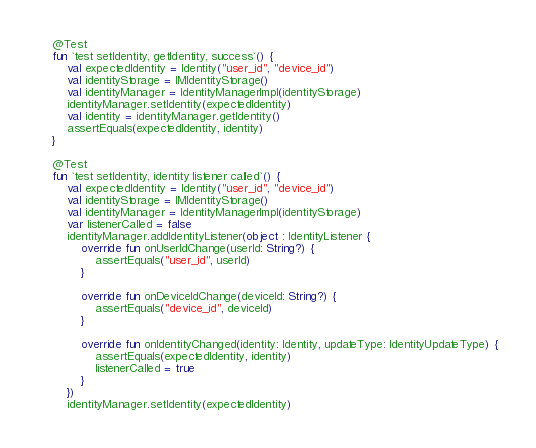Convert code to text. <code><loc_0><loc_0><loc_500><loc_500><_Kotlin_>    @Test
    fun `test setIdentity, getIdentity, success`() {
        val expectedIdentity = Identity("user_id", "device_id")
        val identityStorage = IMIdentityStorage()
        val identityManager = IdentityManagerImpl(identityStorage)
        identityManager.setIdentity(expectedIdentity)
        val identity = identityManager.getIdentity()
        assertEquals(expectedIdentity, identity)
    }

    @Test
    fun `test setIdentity, identity listener called`() {
        val expectedIdentity = Identity("user_id", "device_id")
        val identityStorage = IMIdentityStorage()
        val identityManager = IdentityManagerImpl(identityStorage)
        var listenerCalled = false
        identityManager.addIdentityListener(object : IdentityListener {
            override fun onUserIdChange(userId: String?) {
                assertEquals("user_id", userId)
            }

            override fun onDeviceIdChange(deviceId: String?) {
                assertEquals("device_id", deviceId)
            }

            override fun onIdentityChanged(identity: Identity, updateType: IdentityUpdateType) {
                assertEquals(expectedIdentity, identity)
                listenerCalled = true
            }
        })
        identityManager.setIdentity(expectedIdentity)</code> 